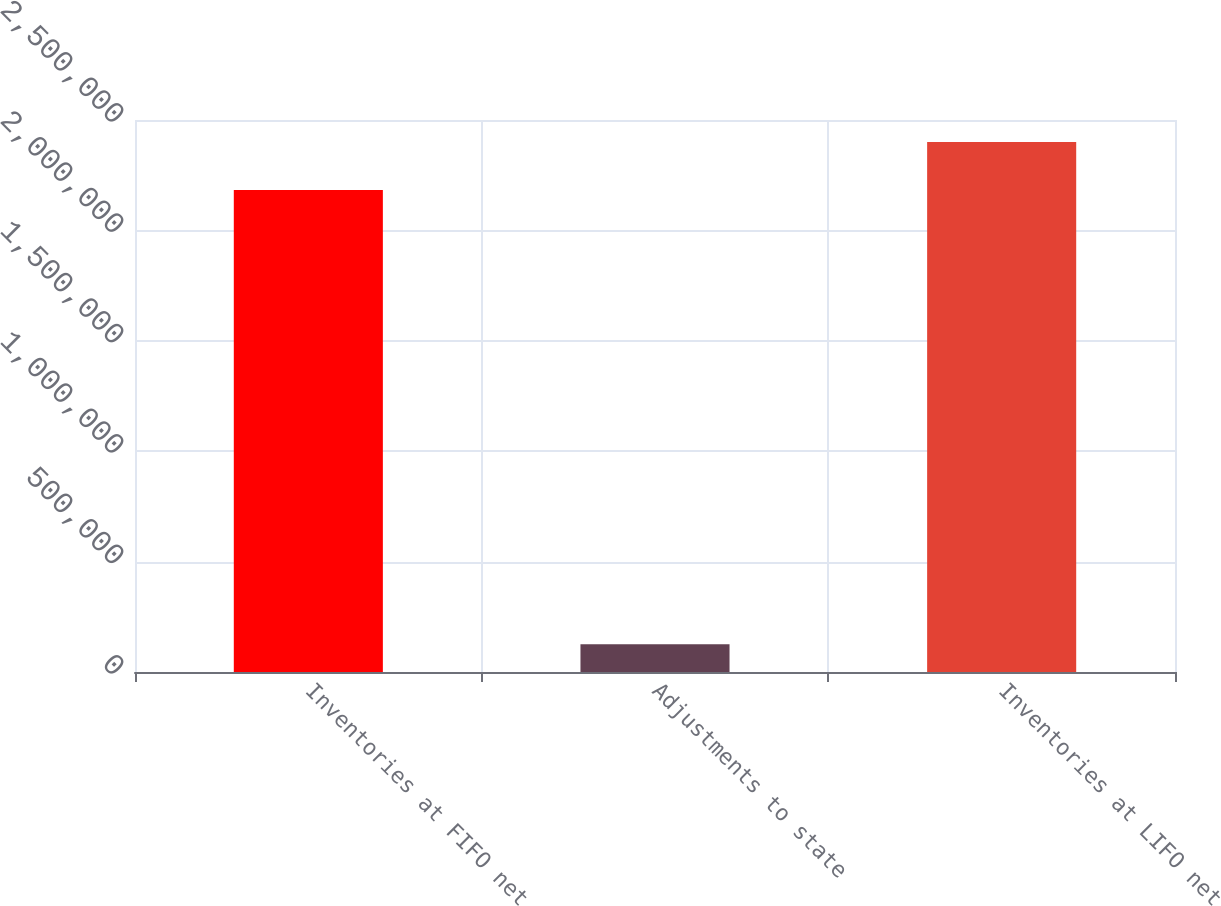<chart> <loc_0><loc_0><loc_500><loc_500><bar_chart><fcel>Inventories at FIFO net<fcel>Adjustments to state<fcel>Inventories at LIFO net<nl><fcel>2.18242e+06<fcel>126190<fcel>2.40066e+06<nl></chart> 